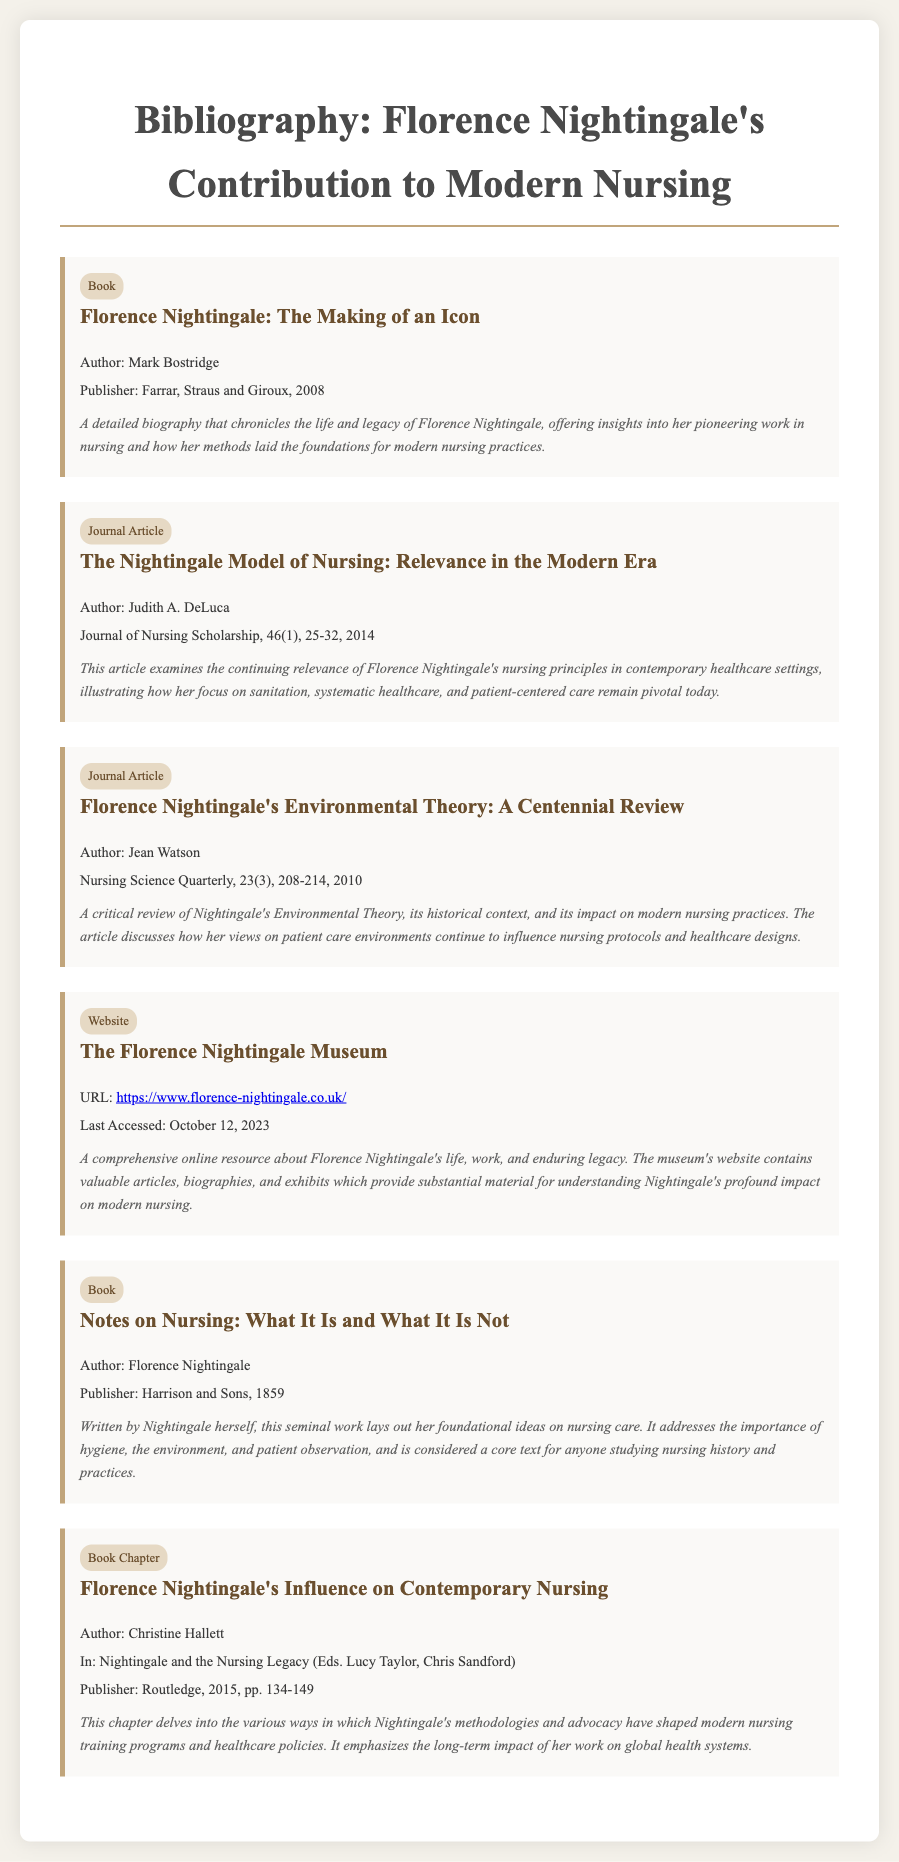What is the title of the biography written by Mark Bostridge? The document lists the book titled "Florence Nightingale: The Making of an Icon" written by Mark Bostridge.
Answer: Florence Nightingale: The Making of an Icon Who is the author of the article examining the relevance of Nightingale's nursing principles? The author of the article "The Nightingale Model of Nursing: Relevance in the Modern Era" is Judith A. DeLuca.
Answer: Judith A. DeLuca In what year was "Notes on Nursing: What It Is and What It Is Not" published? The document states that "Notes on Nursing: What It Is and What It Is Not" was published in 1859.
Answer: 1859 What publisher released the book chapter discussing Nightingale's influence on contemporary nursing? The book chapter by Christine Hallett is published by Routledge.
Answer: Routledge How many pages does the book chapter by Christine Hallett span? The document indicates that the book chapter is on pages 134-149, totaling 16 pages.
Answer: 16 pages What type of resource is "The Florence Nightingale Museum"? The document describes "The Florence Nightingale Museum" as a website.
Answer: Website Which article includes a critical review of Nightingale's Environmental Theory? The article titled "Florence Nightingale's Environmental Theory: A Centennial Review" is the one that includes a critical review.
Answer: Florence Nightingale's Environmental Theory: A Centennial Review Who edited the book containing the chapter on Nightingale's influence? The document lists Lucy Taylor and Chris Sandford as the editors of the book "Nightingale and the Nursing Legacy".
Answer: Lucy Taylor, Chris Sandford 